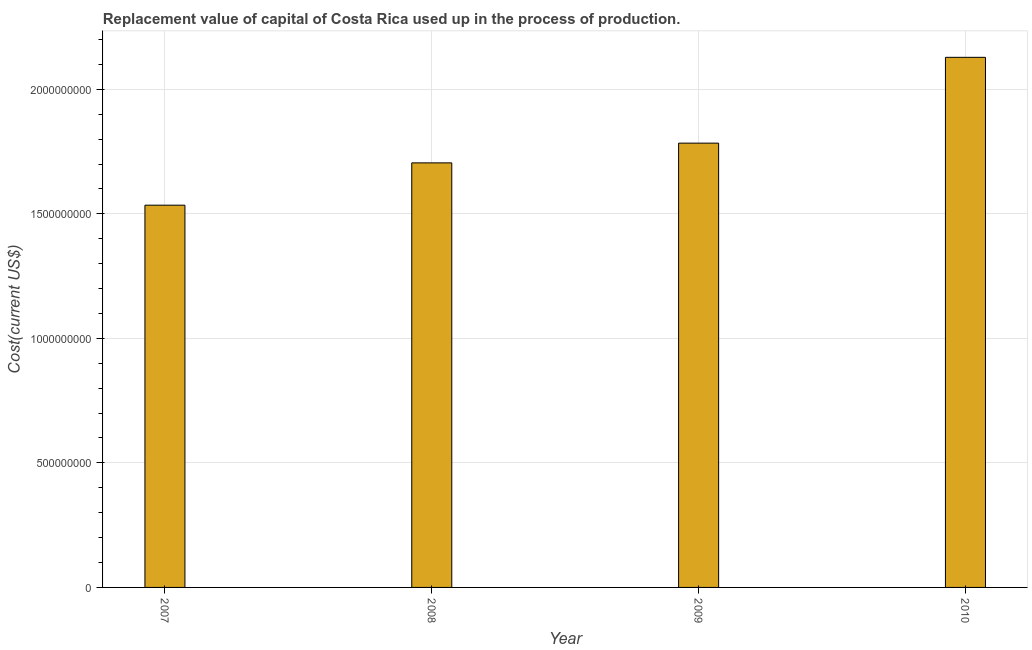What is the title of the graph?
Your answer should be compact. Replacement value of capital of Costa Rica used up in the process of production. What is the label or title of the X-axis?
Your answer should be very brief. Year. What is the label or title of the Y-axis?
Your answer should be compact. Cost(current US$). What is the consumption of fixed capital in 2010?
Keep it short and to the point. 2.13e+09. Across all years, what is the maximum consumption of fixed capital?
Your response must be concise. 2.13e+09. Across all years, what is the minimum consumption of fixed capital?
Keep it short and to the point. 1.53e+09. In which year was the consumption of fixed capital maximum?
Give a very brief answer. 2010. What is the sum of the consumption of fixed capital?
Offer a very short reply. 7.15e+09. What is the difference between the consumption of fixed capital in 2007 and 2009?
Keep it short and to the point. -2.49e+08. What is the average consumption of fixed capital per year?
Ensure brevity in your answer.  1.79e+09. What is the median consumption of fixed capital?
Ensure brevity in your answer.  1.74e+09. Do a majority of the years between 2009 and 2007 (inclusive) have consumption of fixed capital greater than 1600000000 US$?
Keep it short and to the point. Yes. What is the ratio of the consumption of fixed capital in 2008 to that in 2009?
Your answer should be very brief. 0.96. Is the difference between the consumption of fixed capital in 2008 and 2009 greater than the difference between any two years?
Offer a very short reply. No. What is the difference between the highest and the second highest consumption of fixed capital?
Your answer should be compact. 3.45e+08. Is the sum of the consumption of fixed capital in 2008 and 2010 greater than the maximum consumption of fixed capital across all years?
Your response must be concise. Yes. What is the difference between the highest and the lowest consumption of fixed capital?
Keep it short and to the point. 5.94e+08. Are all the bars in the graph horizontal?
Provide a succinct answer. No. Are the values on the major ticks of Y-axis written in scientific E-notation?
Keep it short and to the point. No. What is the Cost(current US$) of 2007?
Your answer should be very brief. 1.53e+09. What is the Cost(current US$) in 2008?
Offer a very short reply. 1.70e+09. What is the Cost(current US$) in 2009?
Your answer should be very brief. 1.78e+09. What is the Cost(current US$) of 2010?
Offer a terse response. 2.13e+09. What is the difference between the Cost(current US$) in 2007 and 2008?
Your response must be concise. -1.70e+08. What is the difference between the Cost(current US$) in 2007 and 2009?
Your response must be concise. -2.49e+08. What is the difference between the Cost(current US$) in 2007 and 2010?
Provide a short and direct response. -5.94e+08. What is the difference between the Cost(current US$) in 2008 and 2009?
Provide a short and direct response. -7.92e+07. What is the difference between the Cost(current US$) in 2008 and 2010?
Provide a short and direct response. -4.24e+08. What is the difference between the Cost(current US$) in 2009 and 2010?
Ensure brevity in your answer.  -3.45e+08. What is the ratio of the Cost(current US$) in 2007 to that in 2009?
Offer a very short reply. 0.86. What is the ratio of the Cost(current US$) in 2007 to that in 2010?
Keep it short and to the point. 0.72. What is the ratio of the Cost(current US$) in 2008 to that in 2009?
Provide a succinct answer. 0.96. What is the ratio of the Cost(current US$) in 2008 to that in 2010?
Ensure brevity in your answer.  0.8. What is the ratio of the Cost(current US$) in 2009 to that in 2010?
Ensure brevity in your answer.  0.84. 